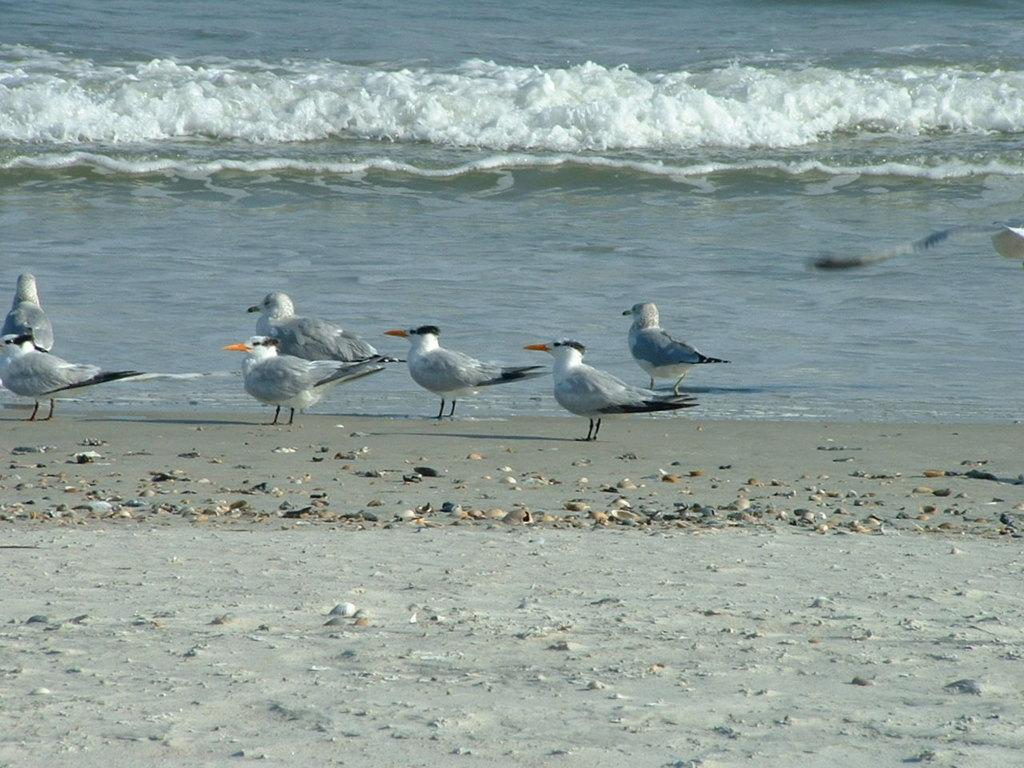What type of animals are on the ground in the image? There is a group of birds on the ground in the image. What can be seen in the background of the image? There is water visible in the background of the image. What type of pin can be seen holding the branch in the image? There is no pin or branch present in the image; it features a group of birds on the ground and water in the background. 